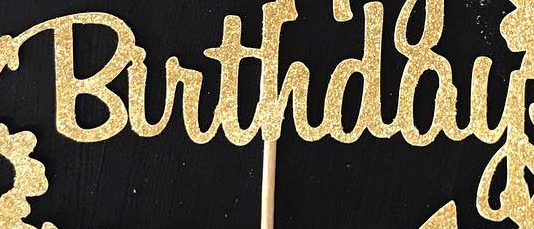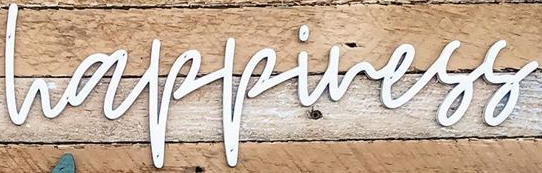Transcribe the words shown in these images in order, separated by a semicolon. Birthday; happiness 